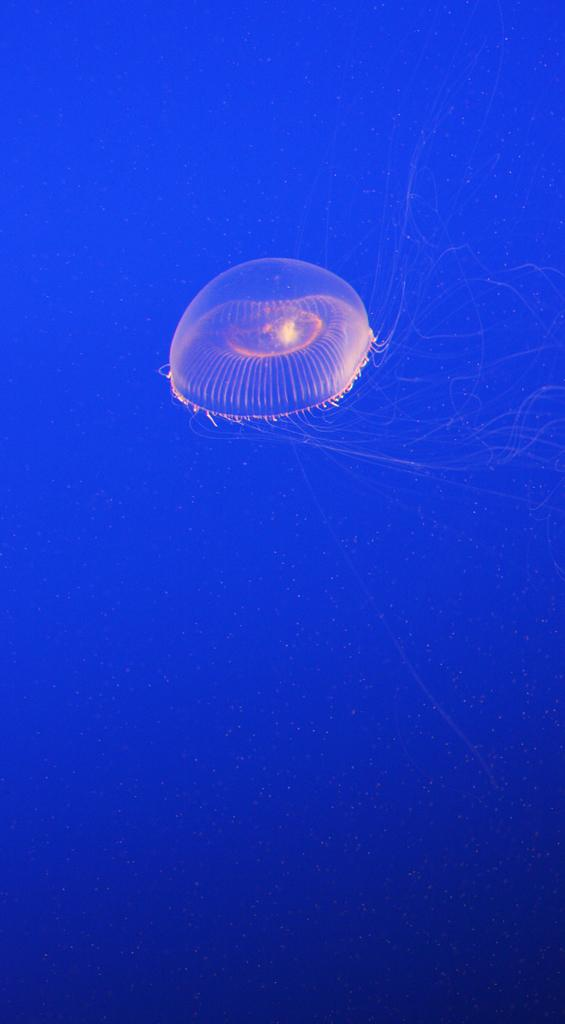What is the main subject of the image? There is a jellyfish in the image. What color is the background of the image? The background of the image is blue. How does the jellyfish express its feelings of hate in the image? There is no indication in the image that the jellyfish is expressing any feelings, let alone hate. 